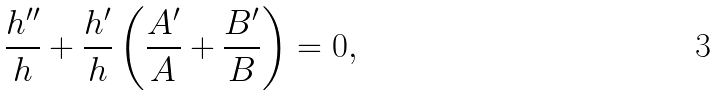Convert formula to latex. <formula><loc_0><loc_0><loc_500><loc_500>\frac { h ^ { \prime \prime } } { h } + \frac { h ^ { \prime } } { h } \left ( \frac { A ^ { \prime } } { A } + \frac { B ^ { \prime } } { B } \right ) = 0 ,</formula> 